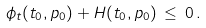Convert formula to latex. <formula><loc_0><loc_0><loc_500><loc_500>\phi _ { t } ( t _ { 0 } , p _ { 0 } ) + H ( t _ { 0 } , p _ { 0 } ) \, \leq \, 0 \, .</formula> 